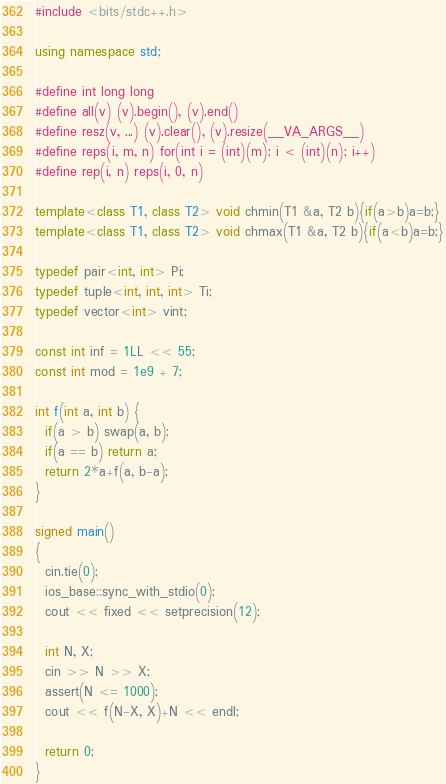<code> <loc_0><loc_0><loc_500><loc_500><_C++_>#include <bits/stdc++.h>

using namespace std;

#define int long long
#define all(v) (v).begin(), (v).end()
#define resz(v, ...) (v).clear(), (v).resize(__VA_ARGS__)
#define reps(i, m, n) for(int i = (int)(m); i < (int)(n); i++)
#define rep(i, n) reps(i, 0, n)

template<class T1, class T2> void chmin(T1 &a, T2 b){if(a>b)a=b;}
template<class T1, class T2> void chmax(T1 &a, T2 b){if(a<b)a=b;}

typedef pair<int, int> Pi;
typedef tuple<int, int, int> Ti;
typedef vector<int> vint;

const int inf = 1LL << 55;
const int mod = 1e9 + 7;

int f(int a, int b) {
  if(a > b) swap(a, b);
  if(a == b) return a;
  return 2*a+f(a, b-a);
}

signed main()
{
  cin.tie(0);
  ios_base::sync_with_stdio(0);
  cout << fixed << setprecision(12);

  int N, X;
  cin >> N >> X;
  assert(N <= 1000);
  cout << f(N-X, X)+N << endl;

  return 0;
}
</code> 